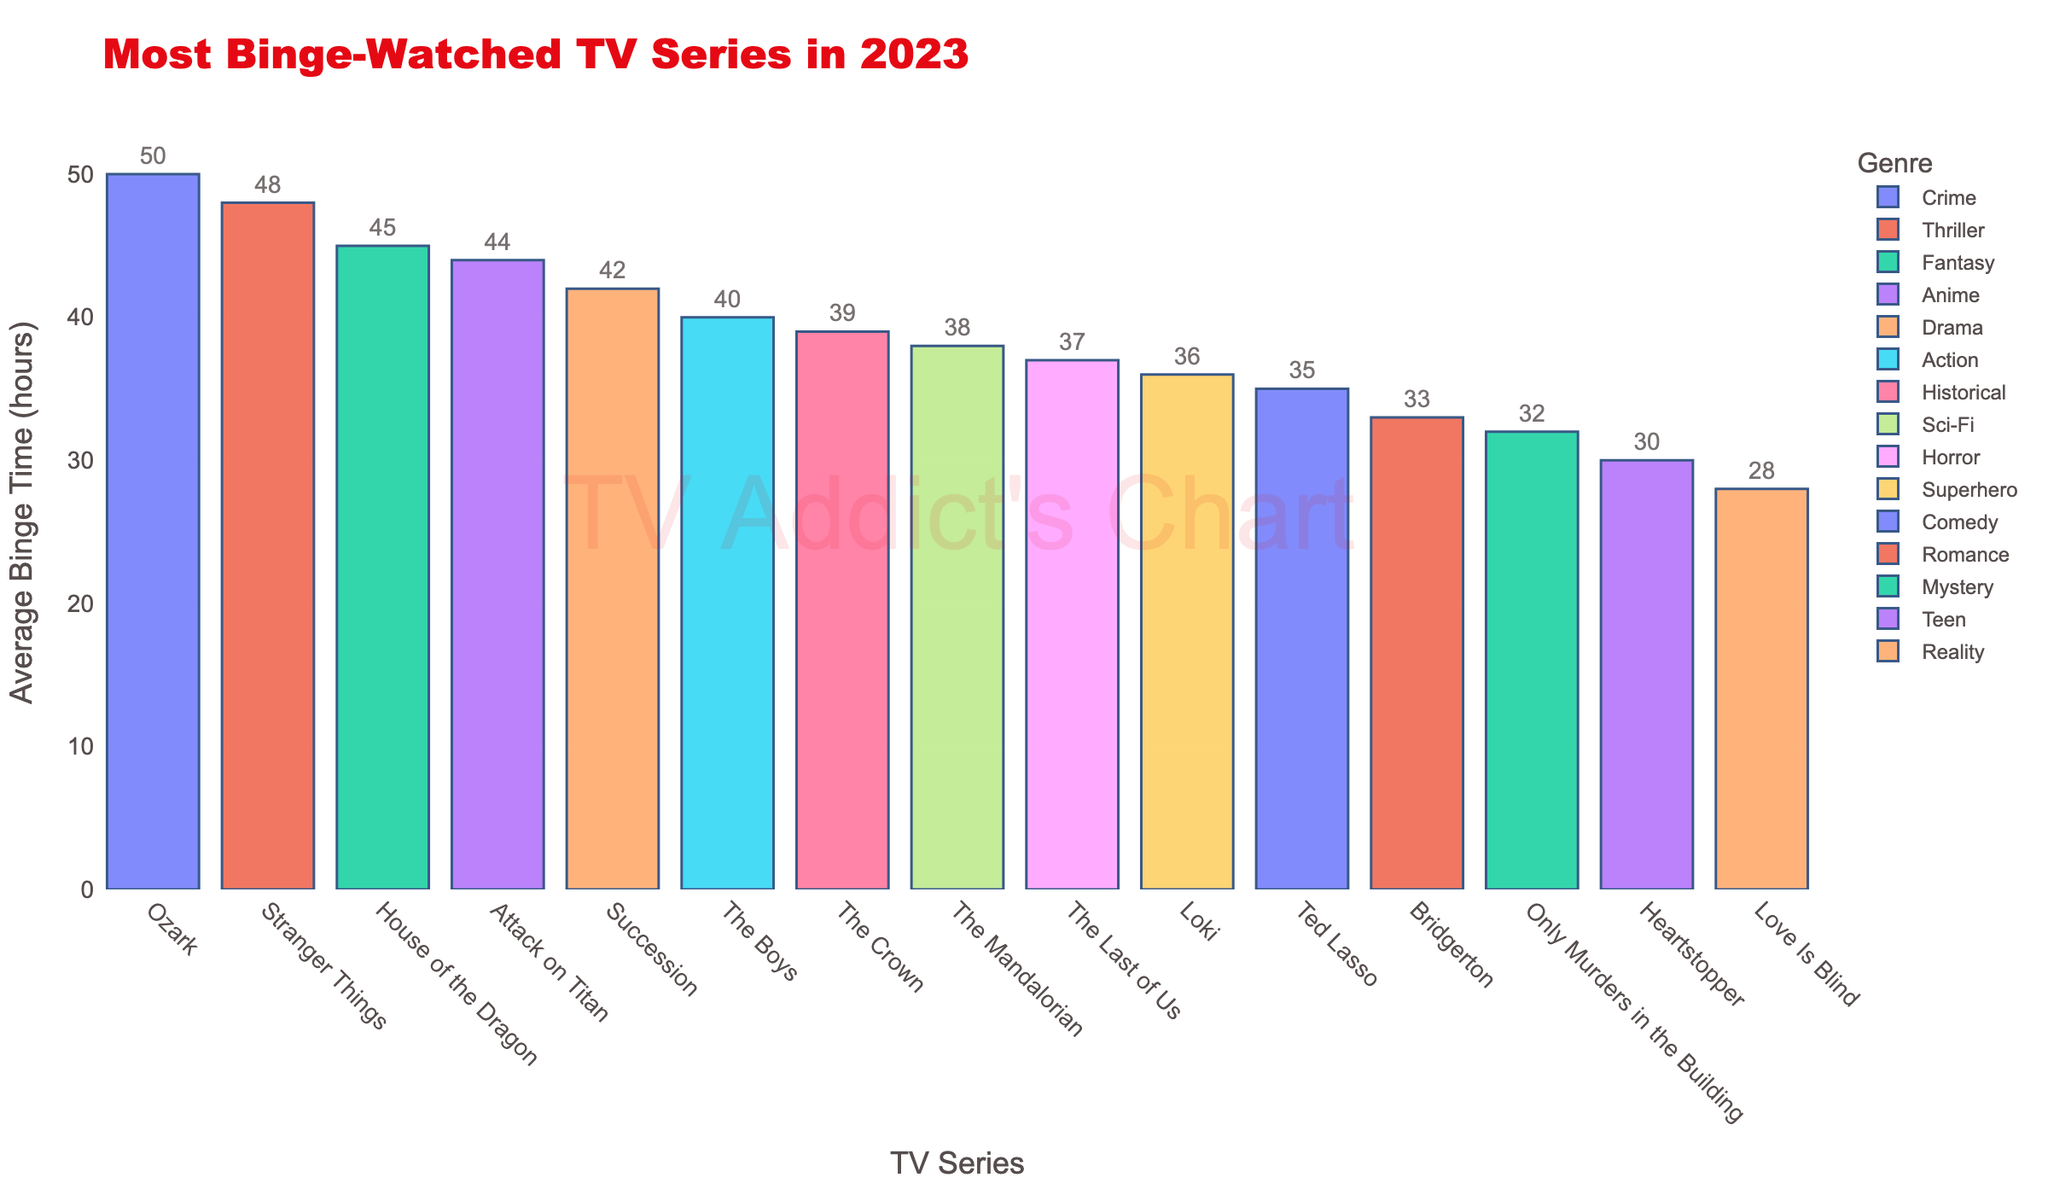Which TV series has the highest average binge time in 2023? The figure indicates the height of the bars to represent the average binge time in hours for each TV series. The bar for "Ozark" reaches the highest value.
Answer: Ozark What is the average binge time for 'Stranger Things' and 'House of the Dragon' combined? The figure shows the average binge times for 'Stranger Things' and 'House of the Dragon' as 48 and 45 hours respectively. Adding these together gives 48 + 45 = 93 hours, and the average is 93 / 2 = 46.5 hours.
Answer: 46.5 hours Which genre's series has the most similar average binge time compared to 'Loki'? The average binge time for 'Loki' (Superhero genre) is 36 hours. Closest binge time to this is 'The Last of Us' (Horror genre) at 37 hours.
Answer: Horror Identify the two genres with the largest difference in average binge time. The figure shows the highest average binge time is for 'Ozark' (Crime) at 50 hours, and the lowest is for 'Love Is Blind' (Reality) at 28 hours. The difference is 50 - 28 = 22 hours.
Answer: Crime and Reality Which series has a higher average binge time, 'Ted Lasso' or 'The Mandalorian'? Comparing the bars visually, 'The Mandalorian' (38 hours) is higher than 'Ted Lasso' (35 hours).
Answer: The Mandalorian What is the color associated with the genre of 'Heartstopper'? In the figure, each genre is represented by a distinct color. By finding 'Heartstopper', we identify its corresponding color.
Answer: The color that represents the Teen genre How much more is the average binge time for 'House of the Dragon' compared to 'Bridgerton'? The figure shows 'House of the Dragon' at 45 hours and 'Bridgerton' at 33 hours. The difference is 45 - 33 = 12 hours.
Answer: 12 hours Which series fall under the genre of Drama and what is their average binge time? According to the figure, 'Succession' is under Drama, and its bar shows an average binge time of 42 hours.
Answer: Succession, 42 hours What is the sum of the average binge times for all series? Summing all the average binge times from the figure: 42 (Succession) + 35 (Ted Lasso) + 38 (The Mandalorian) + 45 (House of the Dragon) + 50 (Ozark) + 33 (Bridgerton) + 48 (Stranger Things) + 40 (The Boys) + 37 (The Last of Us) + 39 (The Crown) + 36 (Loki) + 30 (Heartstopper) + 32 (Only Murders in the Building) + 44 (Attack on Titan) + 28 (Love Is Blind) = 577 hours.
Answer: 577 hours 